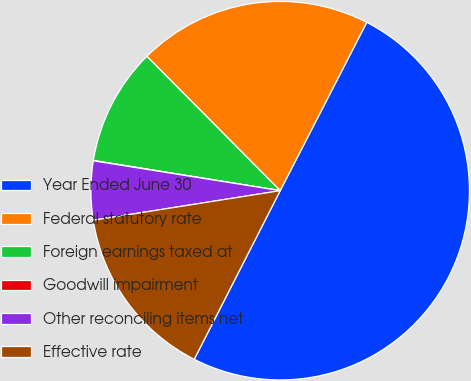Convert chart to OTSL. <chart><loc_0><loc_0><loc_500><loc_500><pie_chart><fcel>Year Ended June 30<fcel>Federal statutory rate<fcel>Foreign earnings taxed at<fcel>Goodwill impairment<fcel>Other reconciling items net<fcel>Effective rate<nl><fcel>49.95%<fcel>20.0%<fcel>10.01%<fcel>0.03%<fcel>5.02%<fcel>15.0%<nl></chart> 